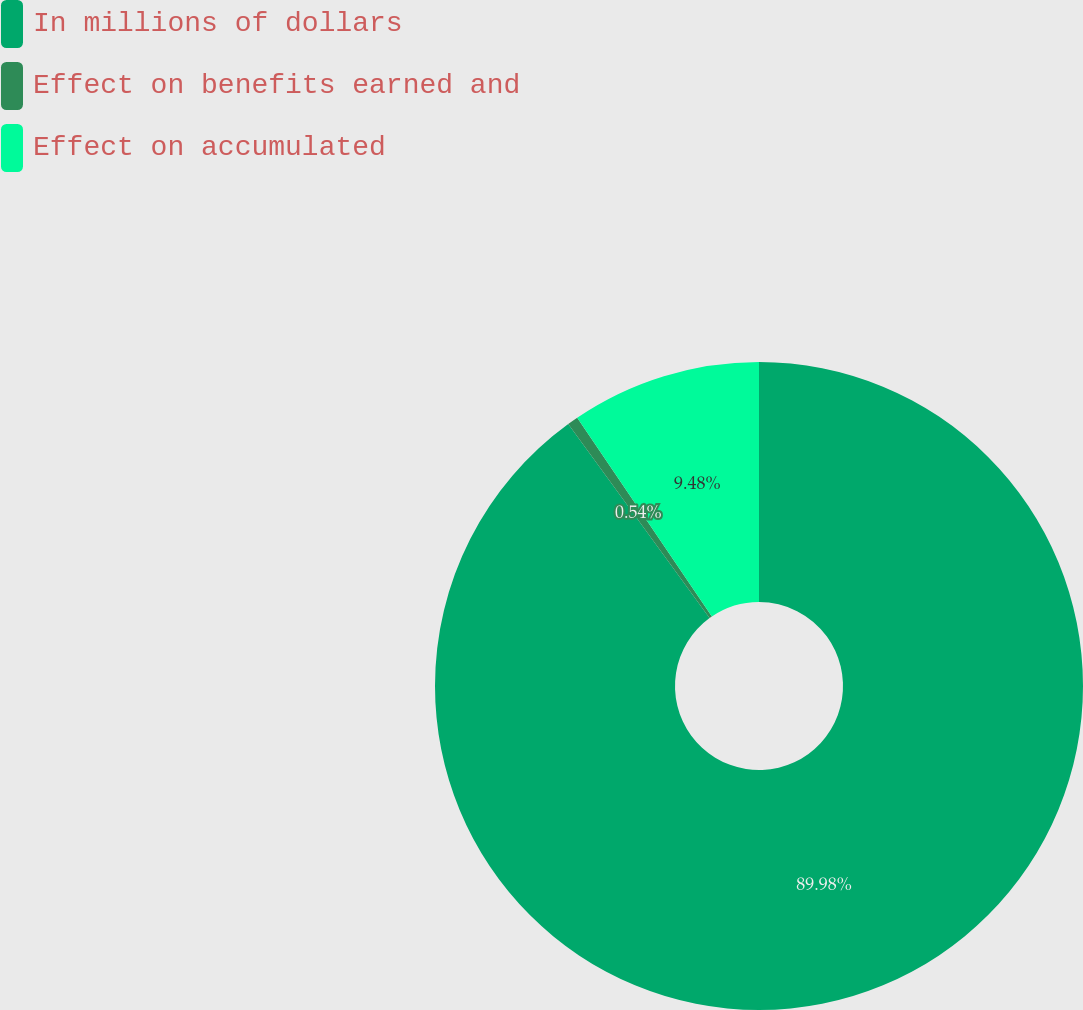<chart> <loc_0><loc_0><loc_500><loc_500><pie_chart><fcel>In millions of dollars<fcel>Effect on benefits earned and<fcel>Effect on accumulated<nl><fcel>89.98%<fcel>0.54%<fcel>9.48%<nl></chart> 